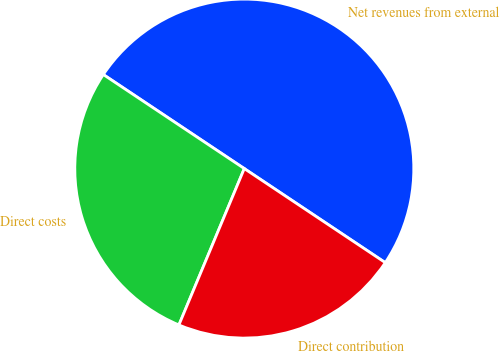<chart> <loc_0><loc_0><loc_500><loc_500><pie_chart><fcel>Net revenues from external<fcel>Direct costs<fcel>Direct contribution<nl><fcel>50.0%<fcel>28.06%<fcel>21.94%<nl></chart> 